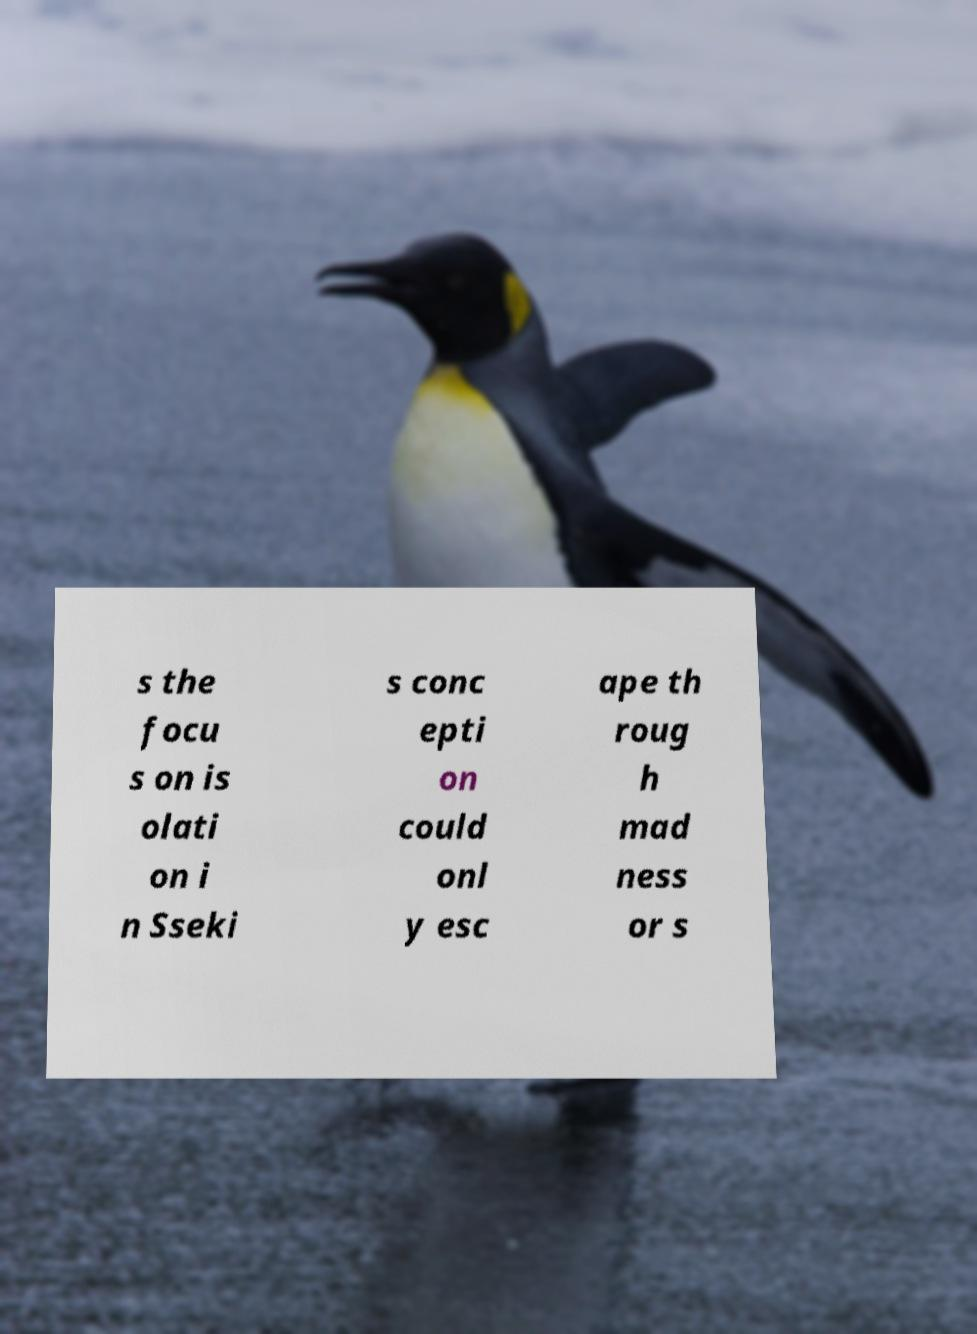I need the written content from this picture converted into text. Can you do that? s the focu s on is olati on i n Sseki s conc epti on could onl y esc ape th roug h mad ness or s 